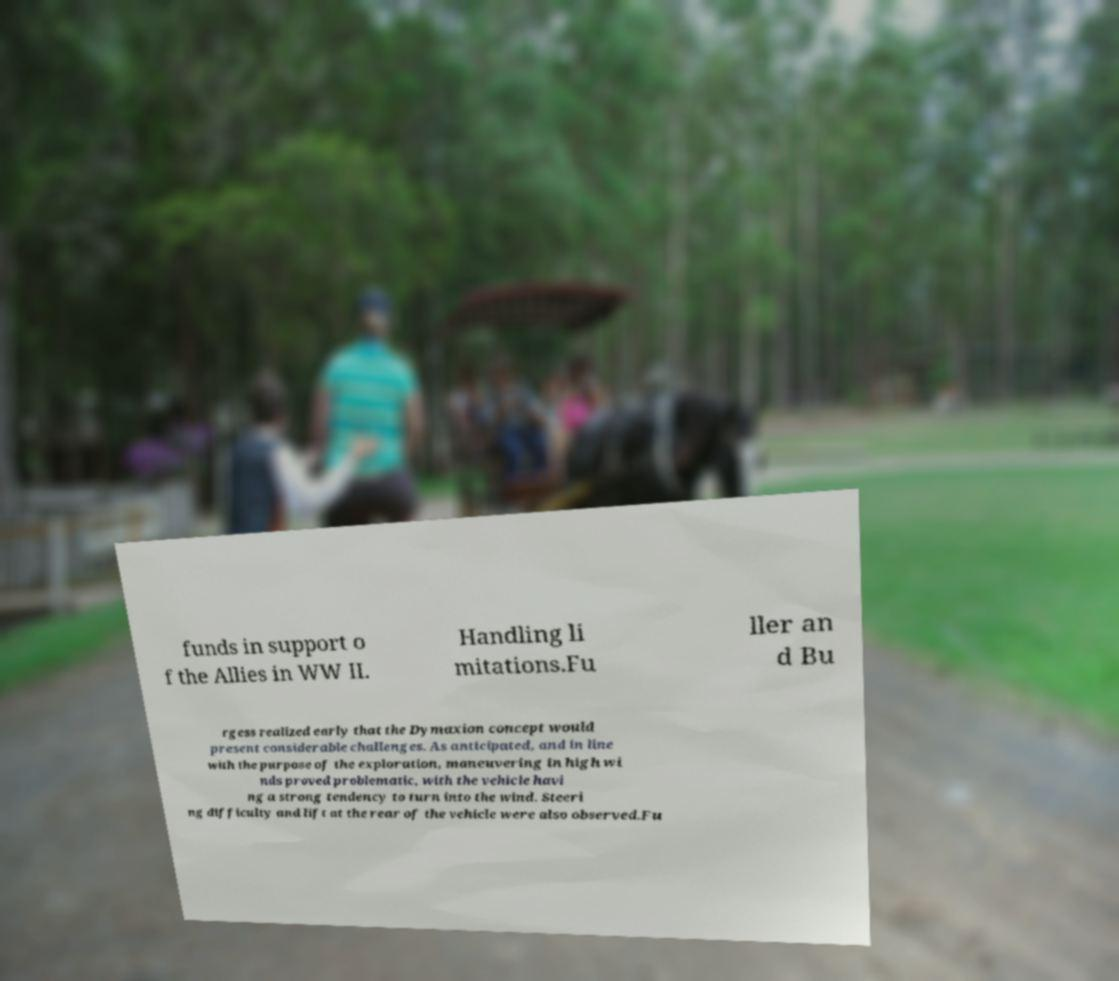Can you accurately transcribe the text from the provided image for me? funds in support o f the Allies in WW II. Handling li mitations.Fu ller an d Bu rgess realized early that the Dymaxion concept would present considerable challenges. As anticipated, and in line with the purpose of the exploration, maneuvering in high wi nds proved problematic, with the vehicle havi ng a strong tendency to turn into the wind. Steeri ng difficulty and lift at the rear of the vehicle were also observed.Fu 